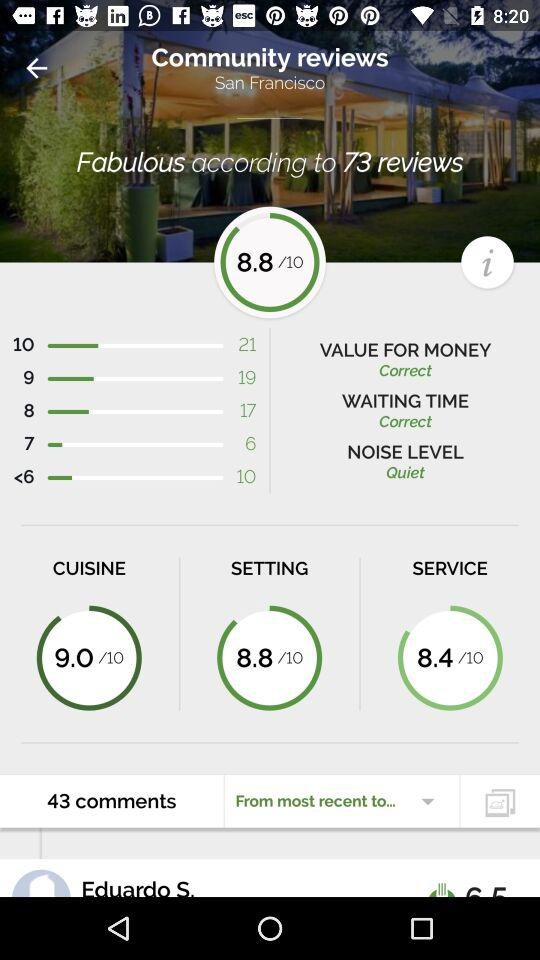What's the number of reviews? The number of reviews is 73. 